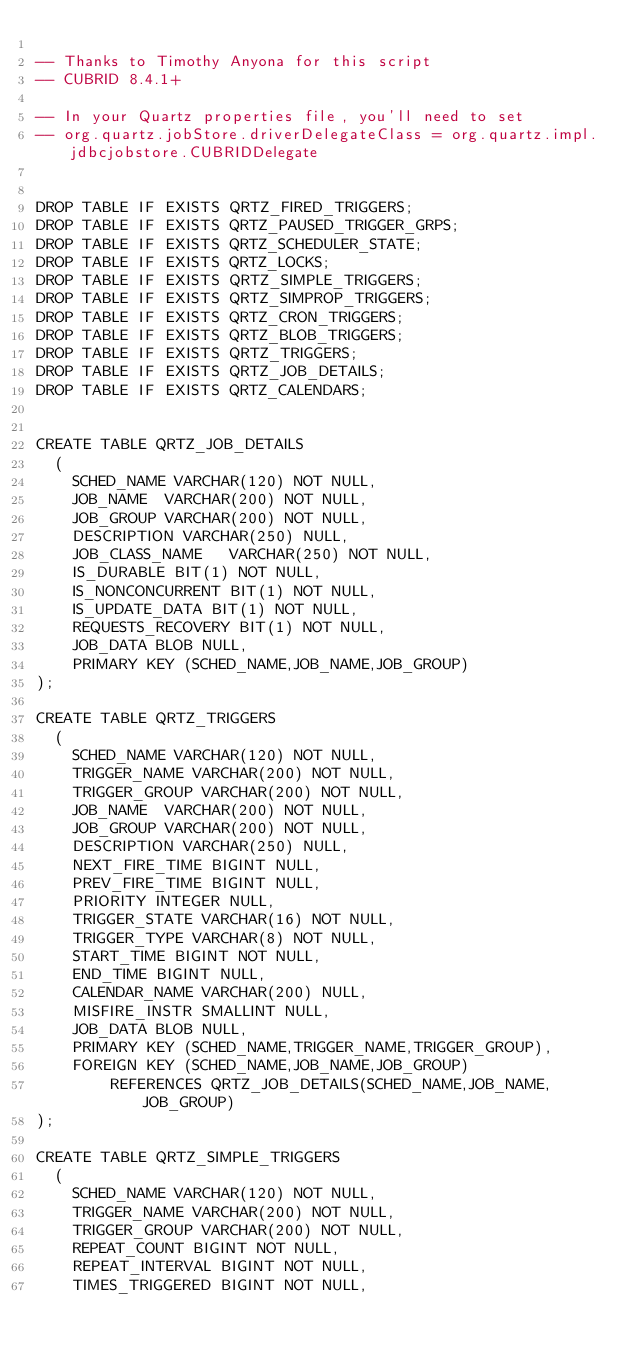<code> <loc_0><loc_0><loc_500><loc_500><_SQL_>
-- Thanks to Timothy Anyona for this script
-- CUBRID 8.4.1+

-- In your Quartz properties file, you'll need to set 
-- org.quartz.jobStore.driverDelegateClass = org.quartz.impl.jdbcjobstore.CUBRIDDelegate


DROP TABLE IF EXISTS QRTZ_FIRED_TRIGGERS;
DROP TABLE IF EXISTS QRTZ_PAUSED_TRIGGER_GRPS;
DROP TABLE IF EXISTS QRTZ_SCHEDULER_STATE;
DROP TABLE IF EXISTS QRTZ_LOCKS;
DROP TABLE IF EXISTS QRTZ_SIMPLE_TRIGGERS;
DROP TABLE IF EXISTS QRTZ_SIMPROP_TRIGGERS;
DROP TABLE IF EXISTS QRTZ_CRON_TRIGGERS;
DROP TABLE IF EXISTS QRTZ_BLOB_TRIGGERS;
DROP TABLE IF EXISTS QRTZ_TRIGGERS;
DROP TABLE IF EXISTS QRTZ_JOB_DETAILS;
DROP TABLE IF EXISTS QRTZ_CALENDARS;


CREATE TABLE QRTZ_JOB_DETAILS
  (
    SCHED_NAME VARCHAR(120) NOT NULL,
    JOB_NAME  VARCHAR(200) NOT NULL,
    JOB_GROUP VARCHAR(200) NOT NULL,
    DESCRIPTION VARCHAR(250) NULL,
    JOB_CLASS_NAME   VARCHAR(250) NOT NULL,
    IS_DURABLE BIT(1) NOT NULL,
    IS_NONCONCURRENT BIT(1) NOT NULL,
    IS_UPDATE_DATA BIT(1) NOT NULL,
    REQUESTS_RECOVERY BIT(1) NOT NULL,
    JOB_DATA BLOB NULL,
    PRIMARY KEY (SCHED_NAME,JOB_NAME,JOB_GROUP)
);

CREATE TABLE QRTZ_TRIGGERS
  (
    SCHED_NAME VARCHAR(120) NOT NULL,
    TRIGGER_NAME VARCHAR(200) NOT NULL,
    TRIGGER_GROUP VARCHAR(200) NOT NULL,
    JOB_NAME  VARCHAR(200) NOT NULL,
    JOB_GROUP VARCHAR(200) NOT NULL,
    DESCRIPTION VARCHAR(250) NULL,
    NEXT_FIRE_TIME BIGINT NULL,
    PREV_FIRE_TIME BIGINT NULL,
    PRIORITY INTEGER NULL,
    TRIGGER_STATE VARCHAR(16) NOT NULL,
    TRIGGER_TYPE VARCHAR(8) NOT NULL,
    START_TIME BIGINT NOT NULL,
    END_TIME BIGINT NULL,
    CALENDAR_NAME VARCHAR(200) NULL,
    MISFIRE_INSTR SMALLINT NULL,
    JOB_DATA BLOB NULL,
    PRIMARY KEY (SCHED_NAME,TRIGGER_NAME,TRIGGER_GROUP),
    FOREIGN KEY (SCHED_NAME,JOB_NAME,JOB_GROUP)
        REFERENCES QRTZ_JOB_DETAILS(SCHED_NAME,JOB_NAME,JOB_GROUP)
);

CREATE TABLE QRTZ_SIMPLE_TRIGGERS
  (
    SCHED_NAME VARCHAR(120) NOT NULL,
    TRIGGER_NAME VARCHAR(200) NOT NULL,
    TRIGGER_GROUP VARCHAR(200) NOT NULL,
    REPEAT_COUNT BIGINT NOT NULL,
    REPEAT_INTERVAL BIGINT NOT NULL,
    TIMES_TRIGGERED BIGINT NOT NULL,</code> 